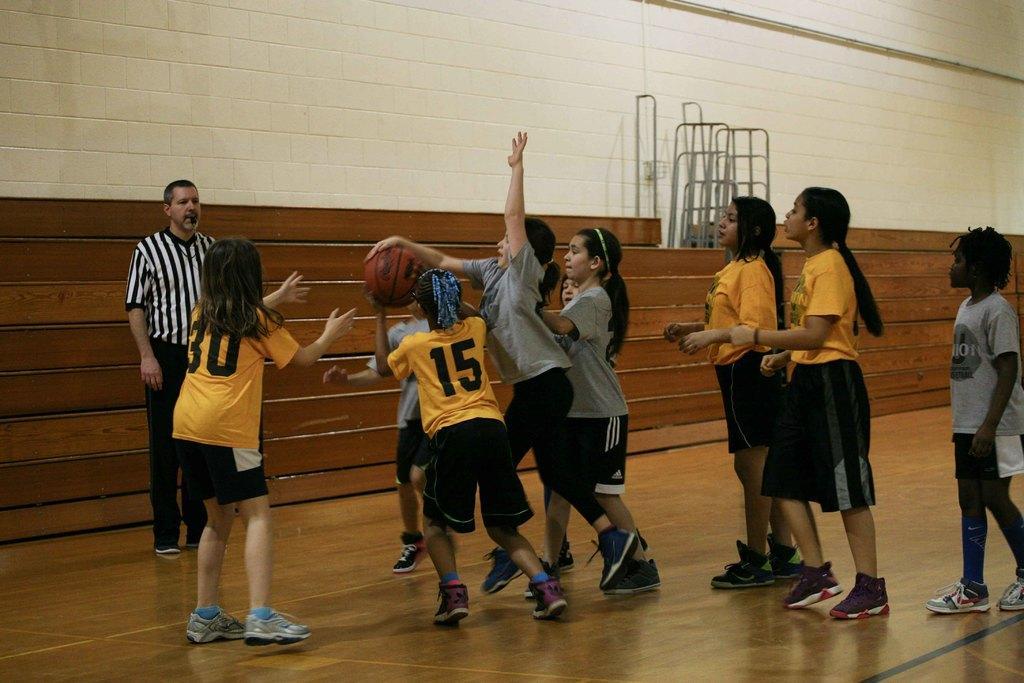How would you summarize this image in a sentence or two? A girl is trying to hit the ball, there are other girls standing, this is a man, this is wall. 